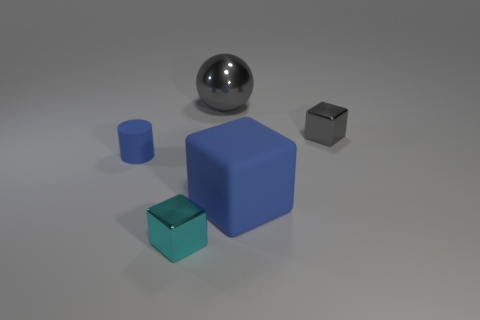Subtract all tiny blocks. How many blocks are left? 1 Add 3 tiny gray metallic objects. How many objects exist? 8 Subtract all cyan blocks. How many blocks are left? 2 Subtract all spheres. How many objects are left? 4 Subtract 1 cubes. How many cubes are left? 2 Add 1 purple spheres. How many purple spheres exist? 1 Subtract 0 green cylinders. How many objects are left? 5 Subtract all purple balls. Subtract all purple cylinders. How many balls are left? 1 Subtract all tiny metal objects. Subtract all big gray objects. How many objects are left? 2 Add 3 gray things. How many gray things are left? 5 